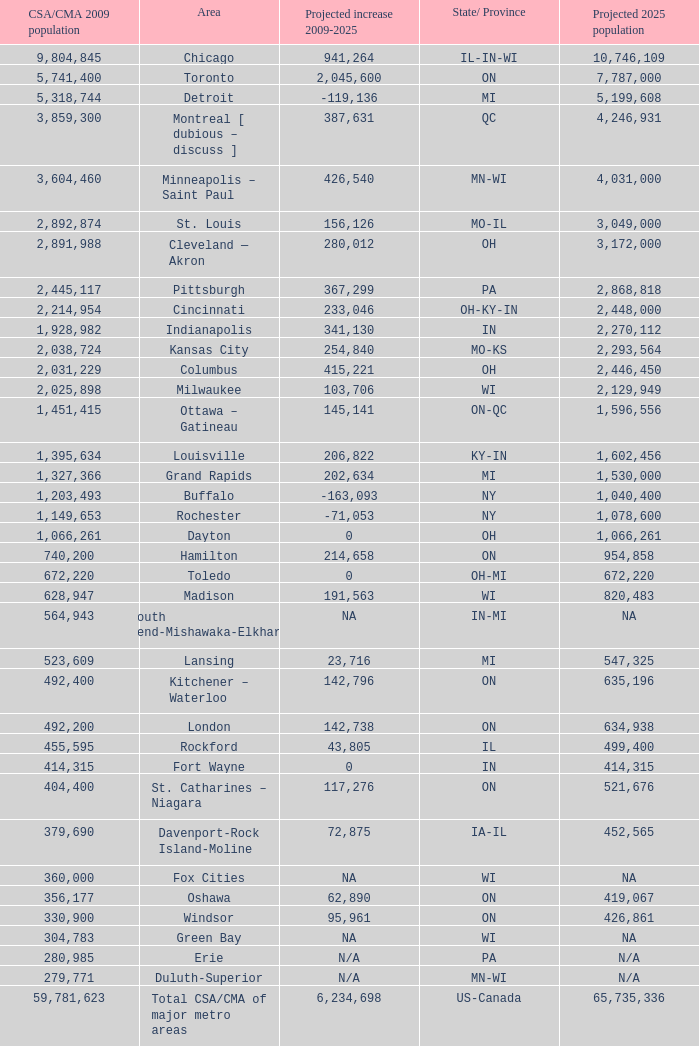What's the projected population of IN-MI? NA. 